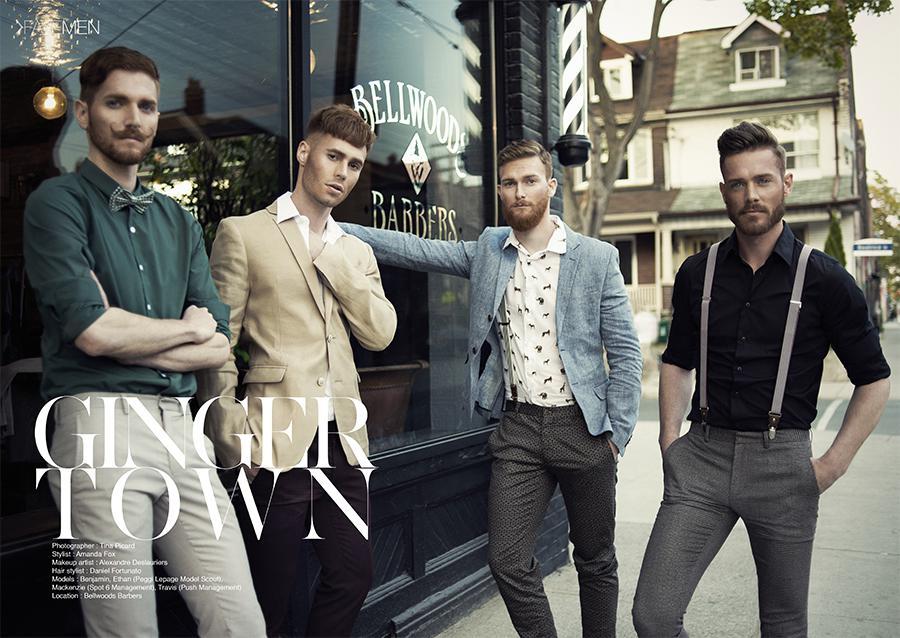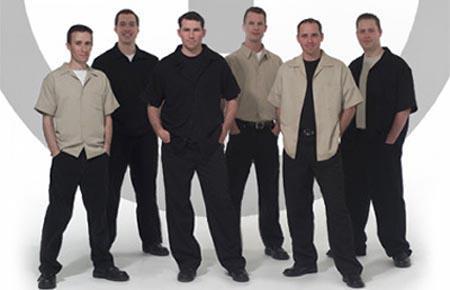The first image is the image on the left, the second image is the image on the right. Examine the images to the left and right. Is the description "A barber in a baseball cap is cutting a mans hair, the person getting their hair cut is wearing a protective cover to shield from the falling hair" accurate? Answer yes or no. No. 